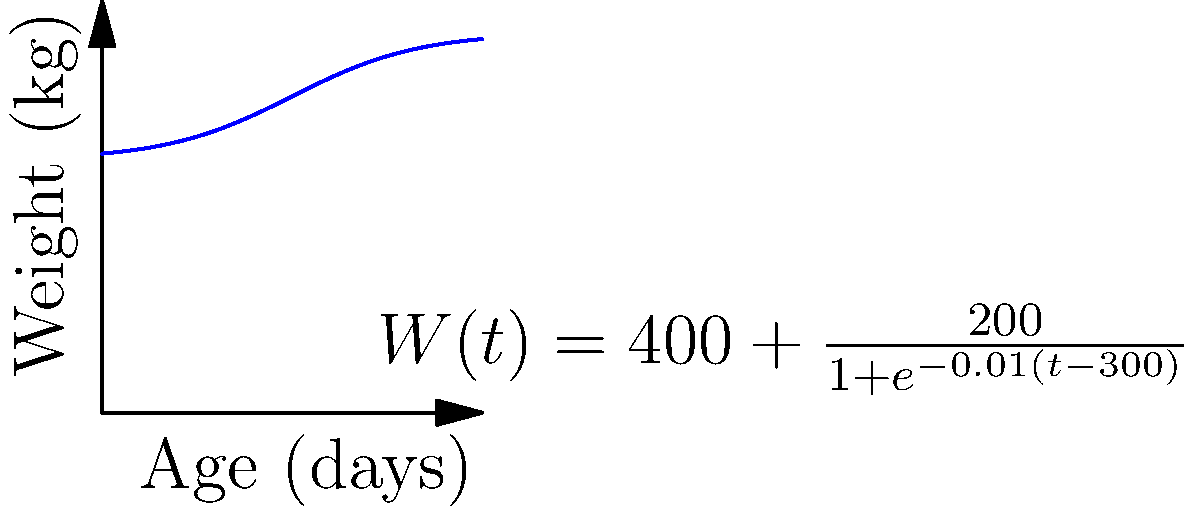As a horse trainer, you're monitoring the growth of a young Arabian horse. The horse's weight (in kg) as a function of age (in days) is given by the logistic function:

$$W(t) = 400 + \frac{200}{1+e^{-0.01(t-300)}}$$

where $t$ is the age in days. Calculate the total weight gain (in kg) of the horse from birth (t = 0) to 600 days old using calculus. Round your answer to the nearest whole number. To find the total weight gain, we need to calculate the area under the growth curve from t = 0 to t = 600. This can be done using a definite integral:

1) Set up the integral:
   $$\int_0^{600} \left(400 + \frac{200}{1+e^{-0.01(t-300)}}\right) dt$$

2) Split the integral:
   $$400 \int_0^{600} dt + 200 \int_0^{600} \frac{1}{1+e^{-0.01(t-300)}} dt$$

3) Evaluate the first part:
   $$400t \bigg|_0^{600} = 240,000$$

4) For the second part, use the substitution $u = e^{-0.01(t-300)}$:
   $$-20,000 \ln(1+u) \bigg|_{e^3}^{e^{-3}}$$

5) Evaluate:
   $$-20,000 [\ln(1+e^{-3}) - \ln(1+e^3)]$$
   $$\approx 119,780.94$$

6) Sum the results:
   $$240,000 + 119,780.94 = 359,780.94$$

7) Subtract the initial weight:
   $$359,780.94 - W(0) = 359,780.94 - 400 = 359,380.94$$

8) Round to the nearest whole number:
   $$359,381 \text{ kg}$$
Answer: 359,381 kg 